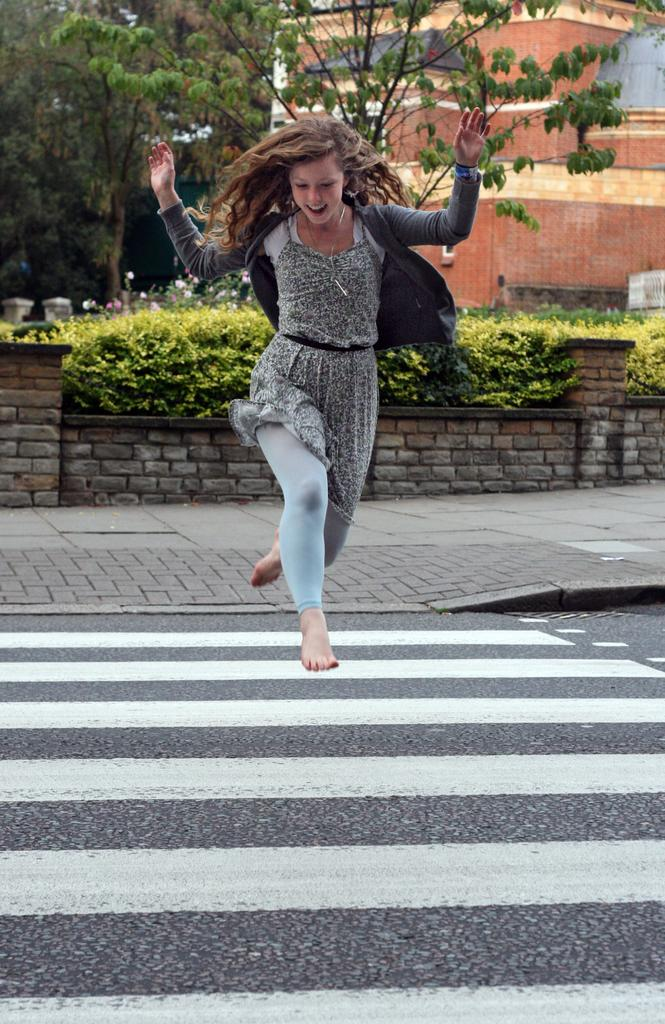What is the main subject of the image? The main subject of the image is a woman. What is the woman doing in the image? The woman is jumping on the road. What can be seen in the background of the image? There are trees and a building visible in the background. What type of destruction can be seen happening to the building in the image? There is no destruction present in the image; the building appears intact. What type of lace can be seen adorning the woman's clothing in the image? There is no lace visible on the woman's clothing in the image. 